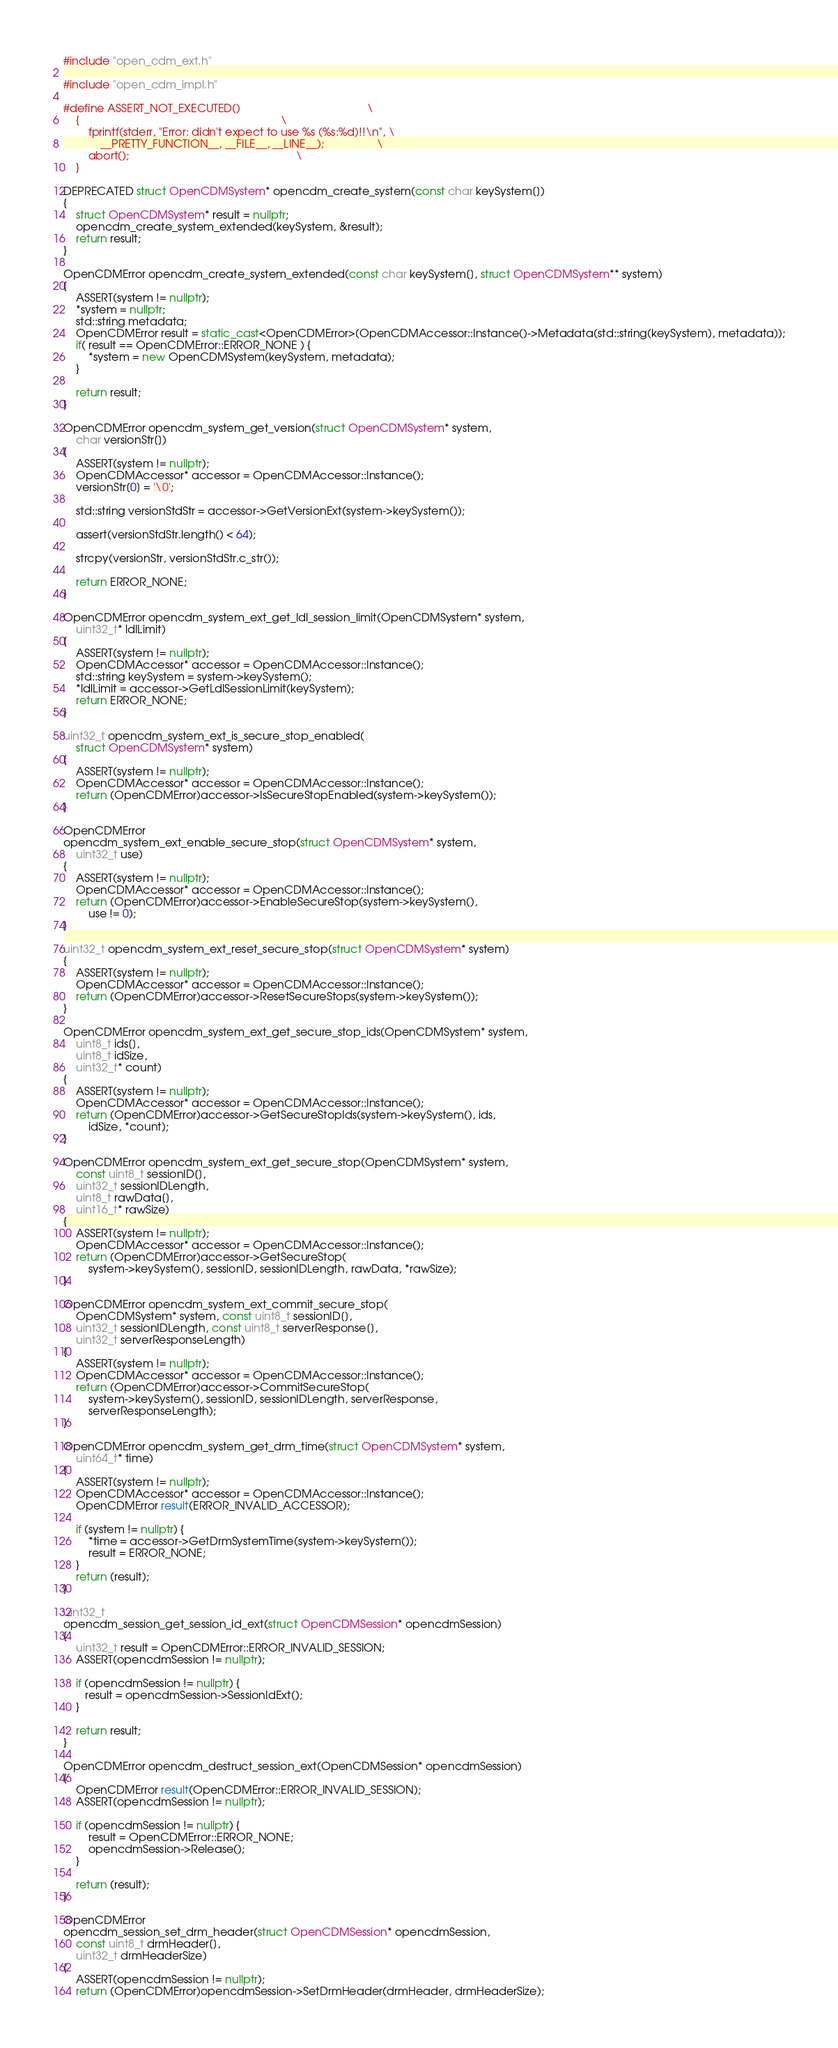Convert code to text. <code><loc_0><loc_0><loc_500><loc_500><_C++_>#include "open_cdm_ext.h"

#include "open_cdm_impl.h"

#define ASSERT_NOT_EXECUTED()                                         \
    {                                                                 \
        fprintf(stderr, "Error: didn't expect to use %s (%s:%d)!!\n", \
            __PRETTY_FUNCTION__, __FILE__, __LINE__);                 \
        abort();                                                      \
    }

DEPRECATED struct OpenCDMSystem* opencdm_create_system(const char keySystem[])
{
    struct OpenCDMSystem* result = nullptr;
    opencdm_create_system_extended(keySystem, &result);
    return result;
}

OpenCDMError opencdm_create_system_extended(const char keySystem[], struct OpenCDMSystem** system)
{
    ASSERT(system != nullptr);
    *system = nullptr;
    std::string metadata;
    OpenCDMError result = static_cast<OpenCDMError>(OpenCDMAccessor::Instance()->Metadata(std::string(keySystem), metadata));
    if( result == OpenCDMError::ERROR_NONE ) {
        *system = new OpenCDMSystem(keySystem, metadata);
    }

    return result;
}

OpenCDMError opencdm_system_get_version(struct OpenCDMSystem* system,
    char versionStr[])
{
    ASSERT(system != nullptr);
    OpenCDMAccessor* accessor = OpenCDMAccessor::Instance();
    versionStr[0] = '\0';

    std::string versionStdStr = accessor->GetVersionExt(system->keySystem());

    assert(versionStdStr.length() < 64);

    strcpy(versionStr, versionStdStr.c_str());

    return ERROR_NONE;
}

OpenCDMError opencdm_system_ext_get_ldl_session_limit(OpenCDMSystem* system,
    uint32_t* ldlLimit)
{
    ASSERT(system != nullptr);
    OpenCDMAccessor* accessor = OpenCDMAccessor::Instance();
    std::string keySystem = system->keySystem();
    *ldlLimit = accessor->GetLdlSessionLimit(keySystem);
    return ERROR_NONE;
}

uint32_t opencdm_system_ext_is_secure_stop_enabled(
    struct OpenCDMSystem* system)
{
    ASSERT(system != nullptr);
    OpenCDMAccessor* accessor = OpenCDMAccessor::Instance();
    return (OpenCDMError)accessor->IsSecureStopEnabled(system->keySystem());
}

OpenCDMError
opencdm_system_ext_enable_secure_stop(struct OpenCDMSystem* system,
    uint32_t use)
{
    ASSERT(system != nullptr);
    OpenCDMAccessor* accessor = OpenCDMAccessor::Instance();
    return (OpenCDMError)accessor->EnableSecureStop(system->keySystem(),
        use != 0);
}

uint32_t opencdm_system_ext_reset_secure_stop(struct OpenCDMSystem* system)
{
    ASSERT(system != nullptr);
    OpenCDMAccessor* accessor = OpenCDMAccessor::Instance();
    return (OpenCDMError)accessor->ResetSecureStops(system->keySystem());
}

OpenCDMError opencdm_system_ext_get_secure_stop_ids(OpenCDMSystem* system,
    uint8_t ids[],
    uint8_t idSize,
    uint32_t* count)
{
    ASSERT(system != nullptr);
    OpenCDMAccessor* accessor = OpenCDMAccessor::Instance();
    return (OpenCDMError)accessor->GetSecureStopIds(system->keySystem(), ids,
        idSize, *count);
}

OpenCDMError opencdm_system_ext_get_secure_stop(OpenCDMSystem* system,
    const uint8_t sessionID[],
    uint32_t sessionIDLength,
    uint8_t rawData[],
    uint16_t* rawSize)
{
    ASSERT(system != nullptr);
    OpenCDMAccessor* accessor = OpenCDMAccessor::Instance();
    return (OpenCDMError)accessor->GetSecureStop(
        system->keySystem(), sessionID, sessionIDLength, rawData, *rawSize);
}

OpenCDMError opencdm_system_ext_commit_secure_stop(
    OpenCDMSystem* system, const uint8_t sessionID[],
    uint32_t sessionIDLength, const uint8_t serverResponse[],
    uint32_t serverResponseLength)
{
    ASSERT(system != nullptr);
    OpenCDMAccessor* accessor = OpenCDMAccessor::Instance();
    return (OpenCDMError)accessor->CommitSecureStop(
        system->keySystem(), sessionID, sessionIDLength, serverResponse,
        serverResponseLength);
}

OpenCDMError opencdm_system_get_drm_time(struct OpenCDMSystem* system,
    uint64_t* time)
{
    ASSERT(system != nullptr);
    OpenCDMAccessor* accessor = OpenCDMAccessor::Instance();
    OpenCDMError result(ERROR_INVALID_ACCESSOR);

    if (system != nullptr) {
        *time = accessor->GetDrmSystemTime(system->keySystem());
        result = ERROR_NONE;
    }
    return (result);
}

uint32_t
opencdm_session_get_session_id_ext(struct OpenCDMSession* opencdmSession)
{
    uint32_t result = OpenCDMError::ERROR_INVALID_SESSION;
    ASSERT(opencdmSession != nullptr);

    if (opencdmSession != nullptr) {
       result = opencdmSession->SessionIdExt();
    }

    return result;
}

OpenCDMError opencdm_destruct_session_ext(OpenCDMSession* opencdmSession)
{
    OpenCDMError result(OpenCDMError::ERROR_INVALID_SESSION);
    ASSERT(opencdmSession != nullptr);

    if (opencdmSession != nullptr) {
        result = OpenCDMError::ERROR_NONE;
        opencdmSession->Release();
    }

    return (result);
}

OpenCDMError
opencdm_session_set_drm_header(struct OpenCDMSession* opencdmSession,
    const uint8_t drmHeader[],
    uint32_t drmHeaderSize)
{
    ASSERT(opencdmSession != nullptr);
    return (OpenCDMError)opencdmSession->SetDrmHeader(drmHeader, drmHeaderSize);</code> 